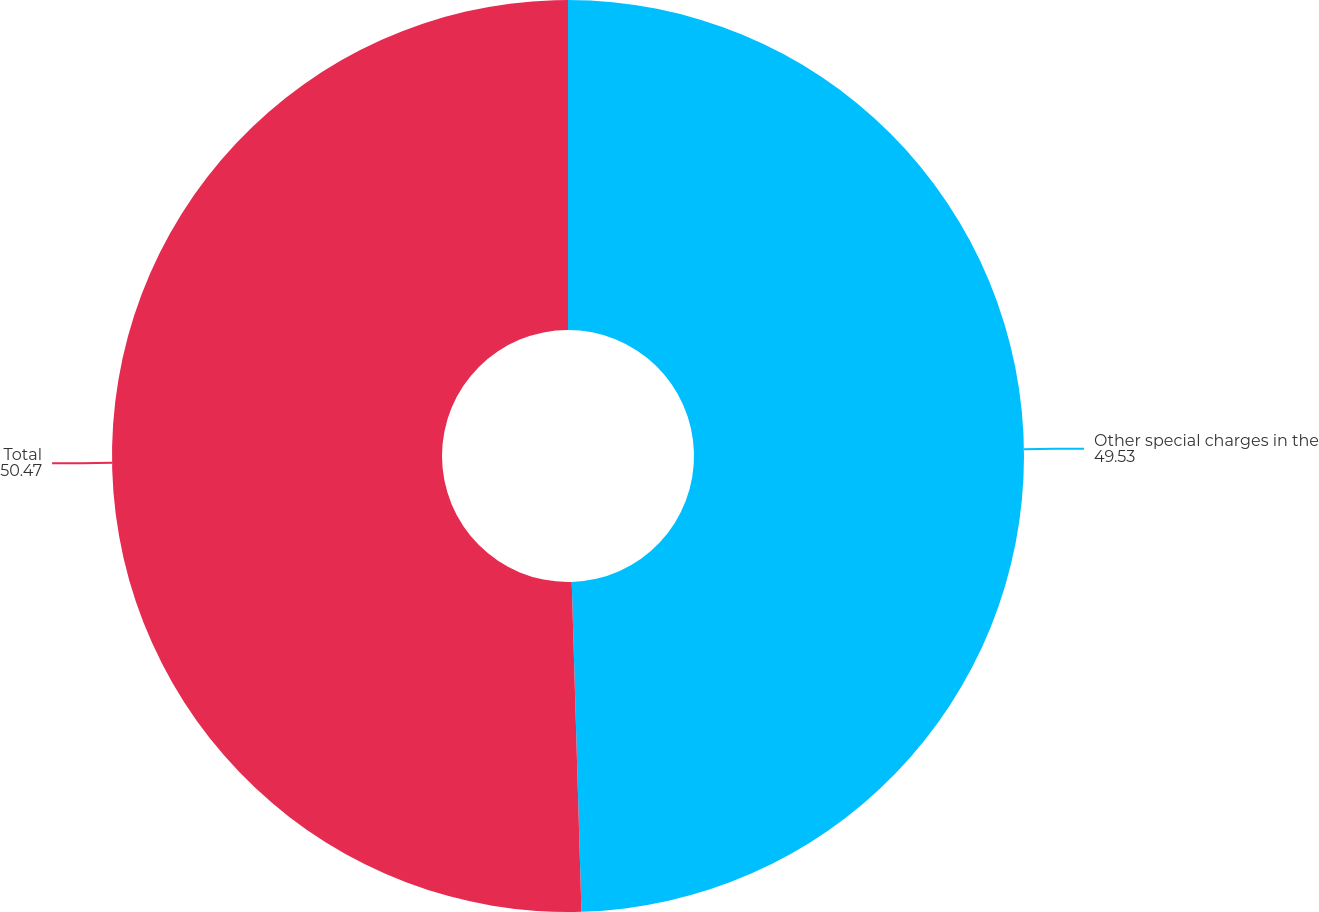<chart> <loc_0><loc_0><loc_500><loc_500><pie_chart><fcel>Other special charges in the<fcel>Total<nl><fcel>49.53%<fcel>50.47%<nl></chart> 